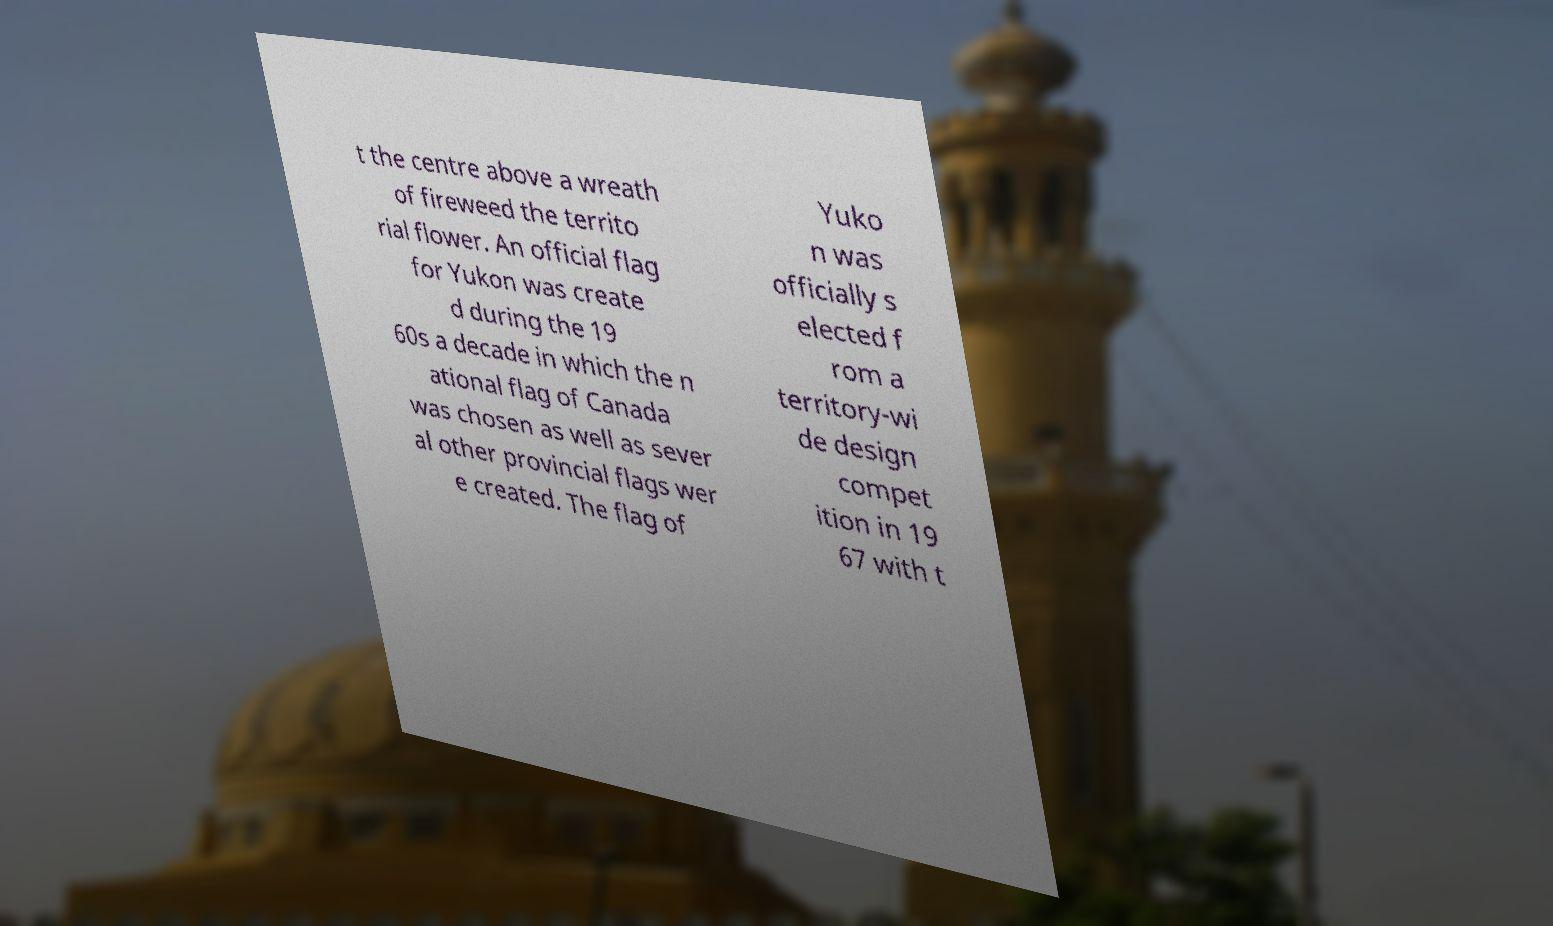Could you extract and type out the text from this image? t the centre above a wreath of fireweed the territo rial flower. An official flag for Yukon was create d during the 19 60s a decade in which the n ational flag of Canada was chosen as well as sever al other provincial flags wer e created. The flag of Yuko n was officially s elected f rom a territory-wi de design compet ition in 19 67 with t 